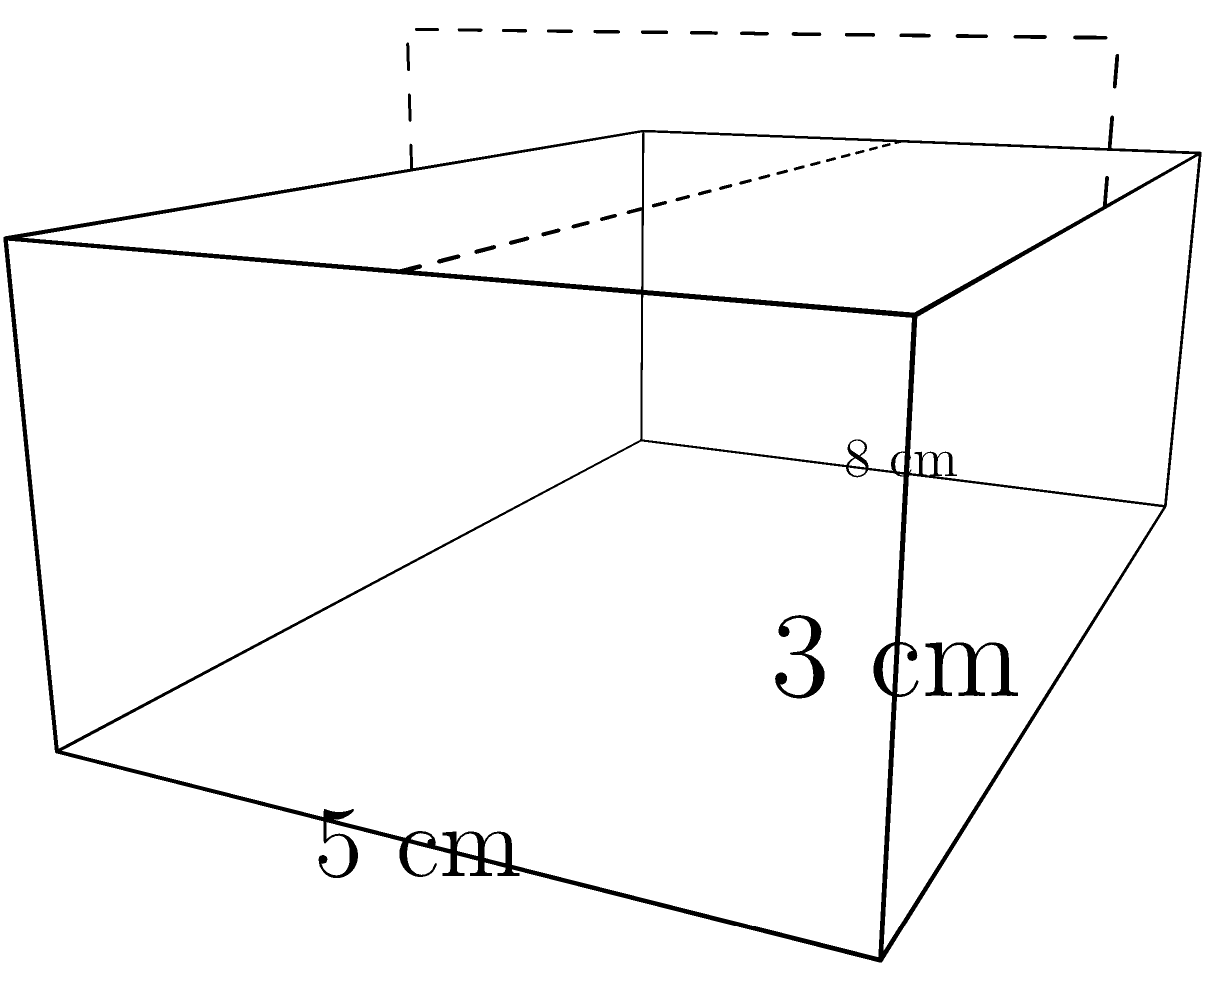A family heirloom wooden jewelry box, cherished for generations, measures 8 cm in length, 5 cm in width, and 3 cm in height. If a heartfelt letter is placed inside, occupying half the box's volume, what is the remaining volume available for storing small keepsakes? To solve this problem, let's follow these steps:

1. Calculate the total volume of the jewelry box:
   $V_{total} = length \times width \times height$
   $V_{total} = 8 \text{ cm} \times 5 \text{ cm} \times 3 \text{ cm} = 120 \text{ cm}^3$

2. Determine the volume occupied by the heartfelt letter:
   The letter occupies half the box's volume, so:
   $V_{letter} = \frac{1}{2} \times V_{total} = \frac{1}{2} \times 120 \text{ cm}^3 = 60 \text{ cm}^3$

3. Calculate the remaining volume for keepsakes:
   $V_{remaining} = V_{total} - V_{letter}$
   $V_{remaining} = 120 \text{ cm}^3 - 60 \text{ cm}^3 = 60 \text{ cm}^3$

Therefore, the remaining volume available for storing small keepsakes is 60 cm³.
Answer: 60 cm³ 